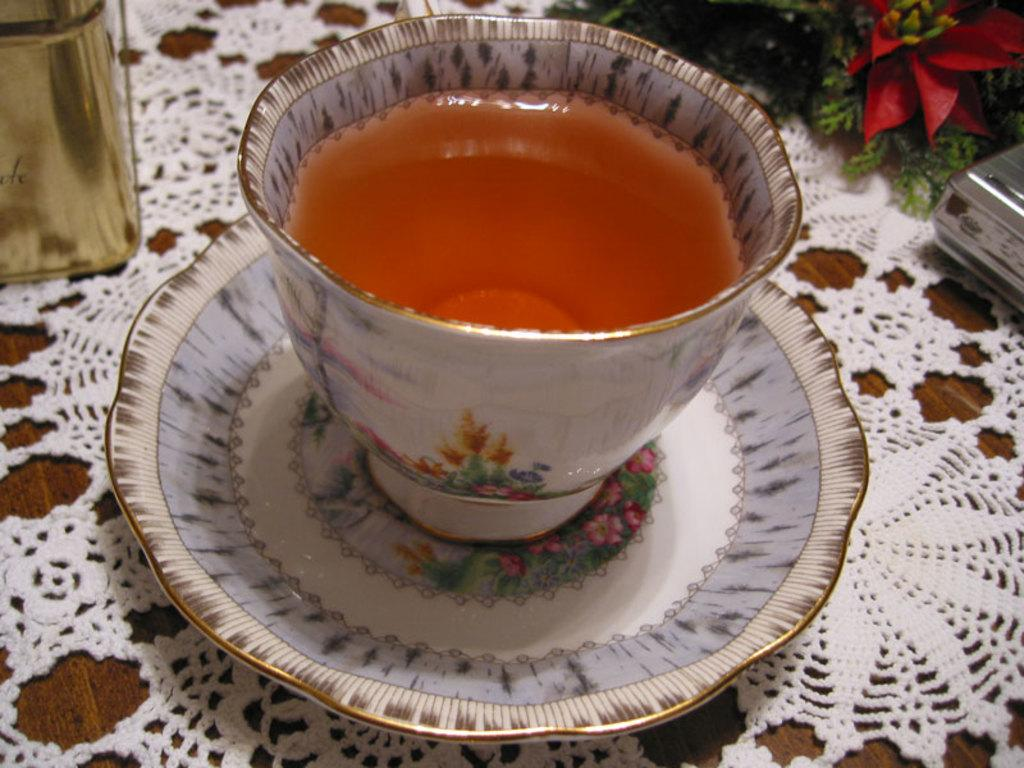What piece of furniture is present in the image? There is a table in the image. Where is the table located in the image? The table is located at the bottom of the image. What items can be seen on the table? There is a cup and saucer, a flower bouquet, and some other objects on the table. Is there a beggar asking for money near the table in the image? No, there is no beggar present in the image. Can you see a sink in the image? No, there is no sink present in the image. 